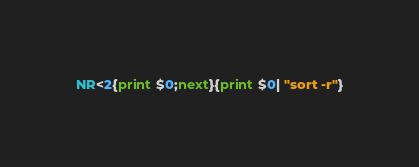Convert code to text. <code><loc_0><loc_0><loc_500><loc_500><_Awk_>NR<2{print $0;next}{print $0| "sort -r"}
</code> 